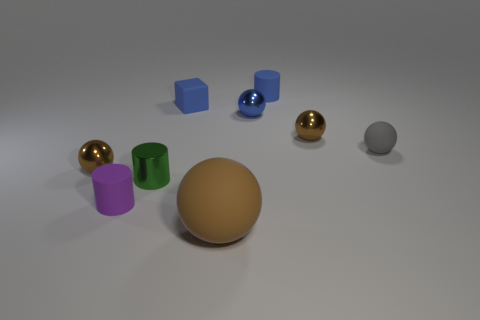Do the tiny rubber sphere and the tiny cube have the same color? The small rubber sphere and the cube do not share the same color. In the image, the sphere appears to be a golden hue, whereas the cube is distinctly blue. 